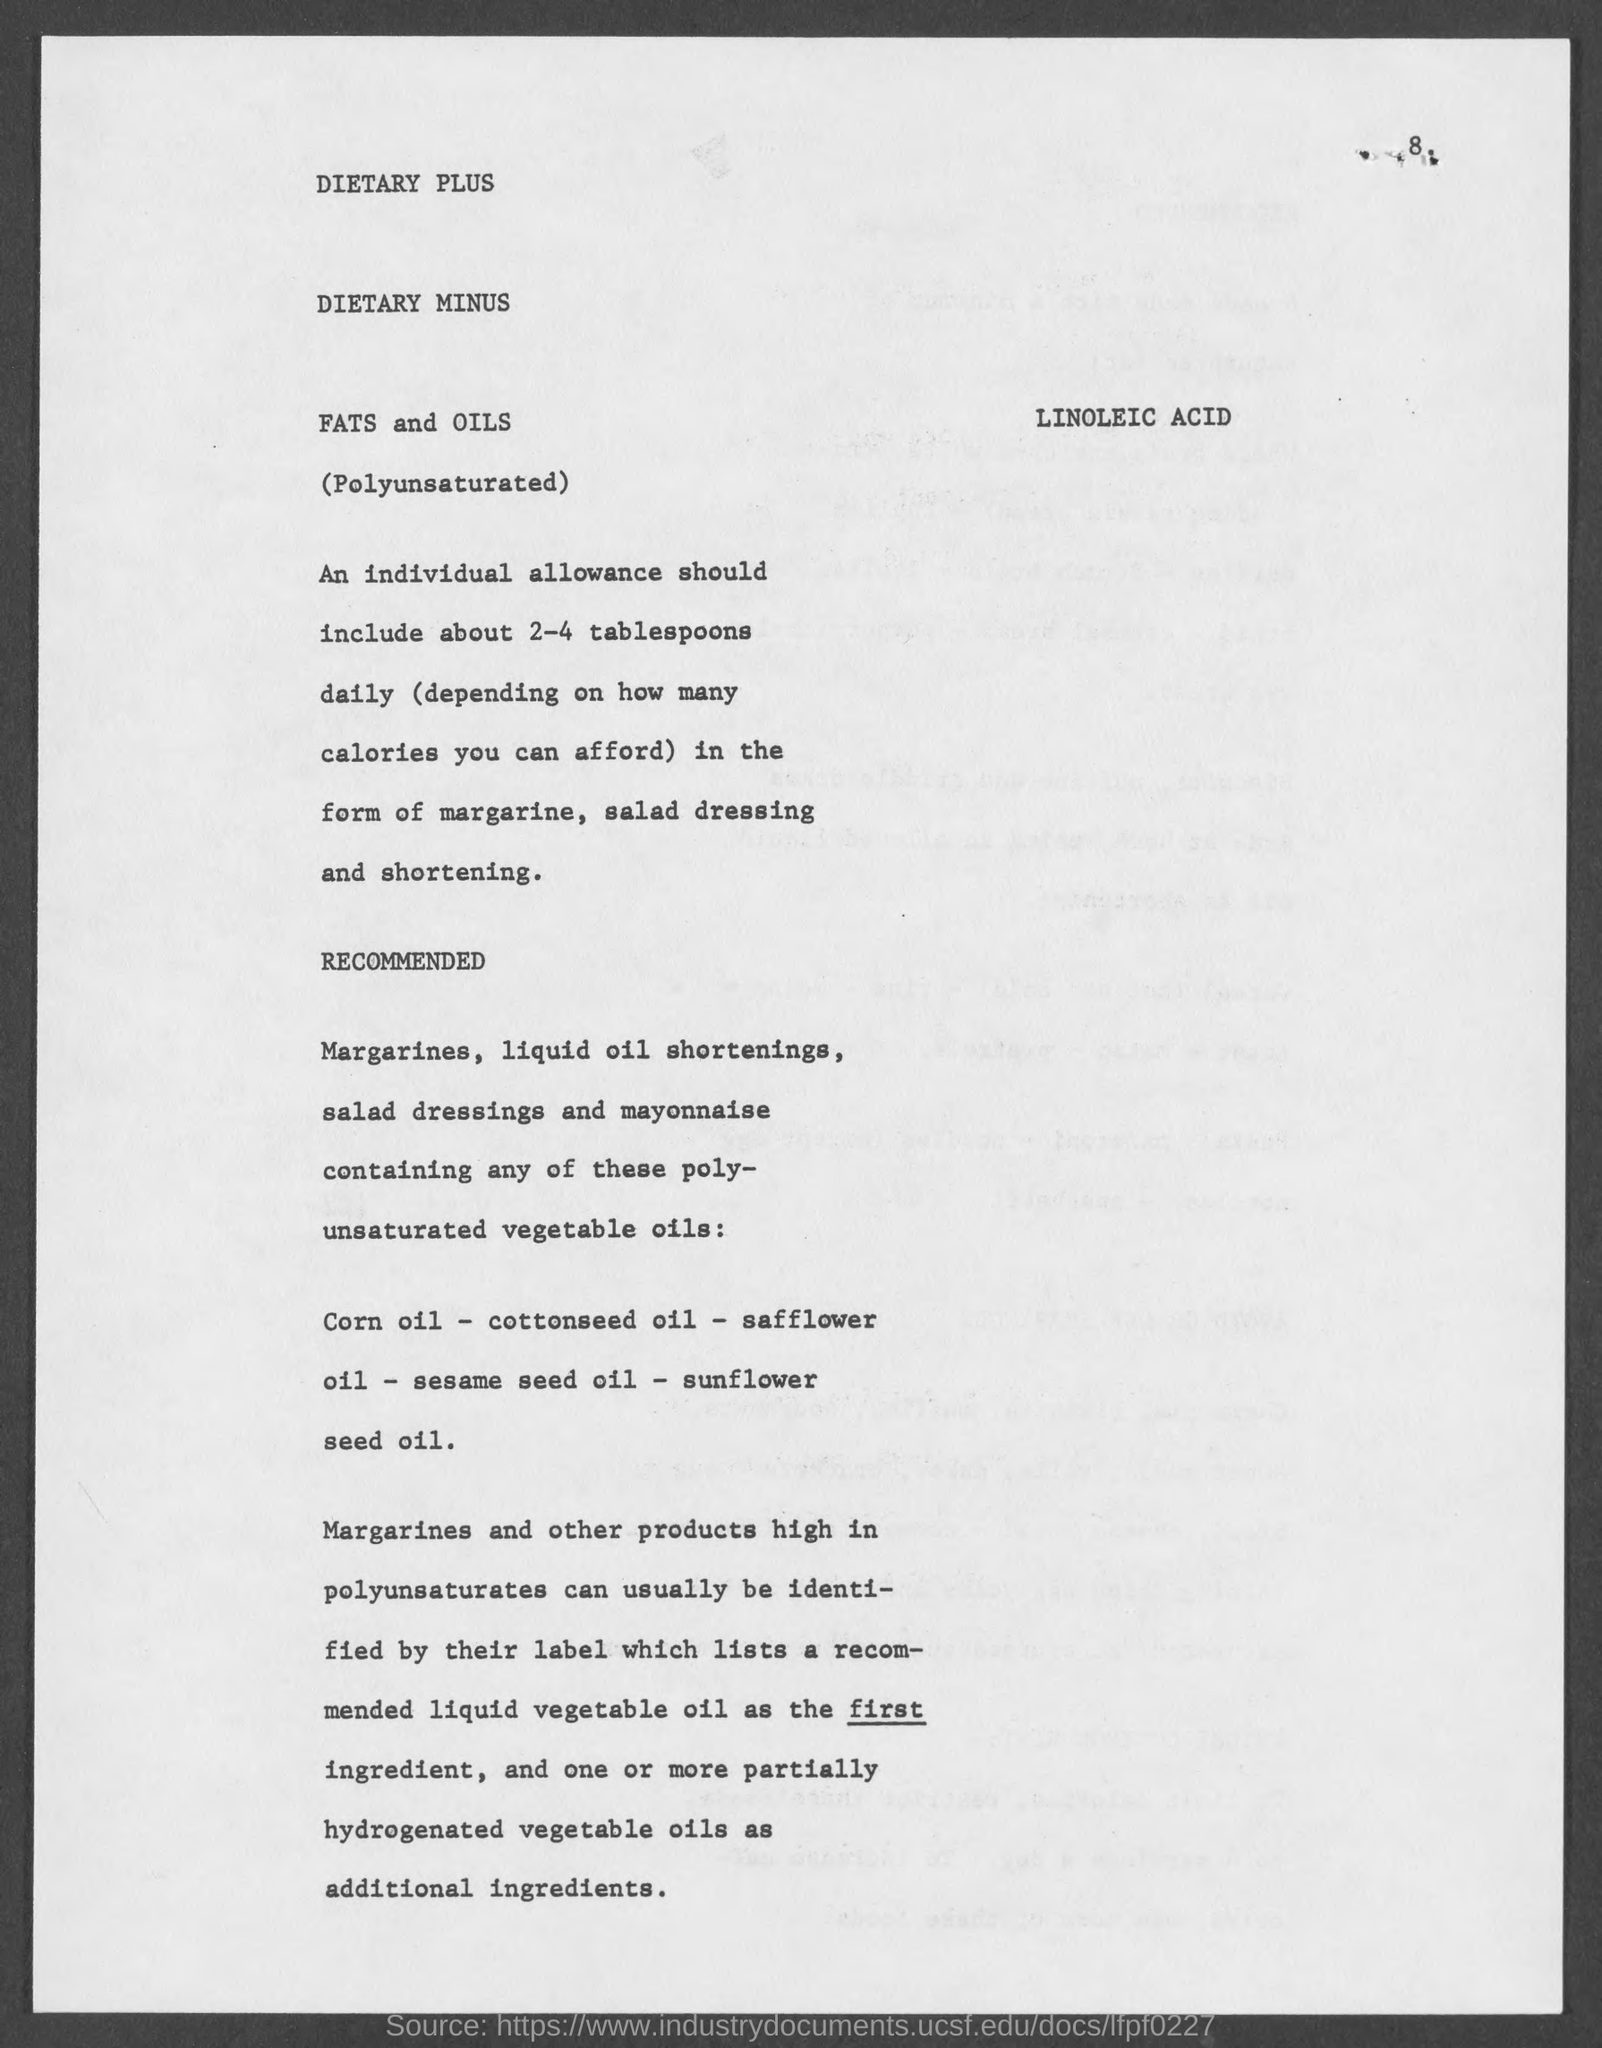Identify some key points in this picture. The recommended daily intake of tablespoons for margarine, salad dressing, and shortening is 2 to 4 tablespoons for an individual. 